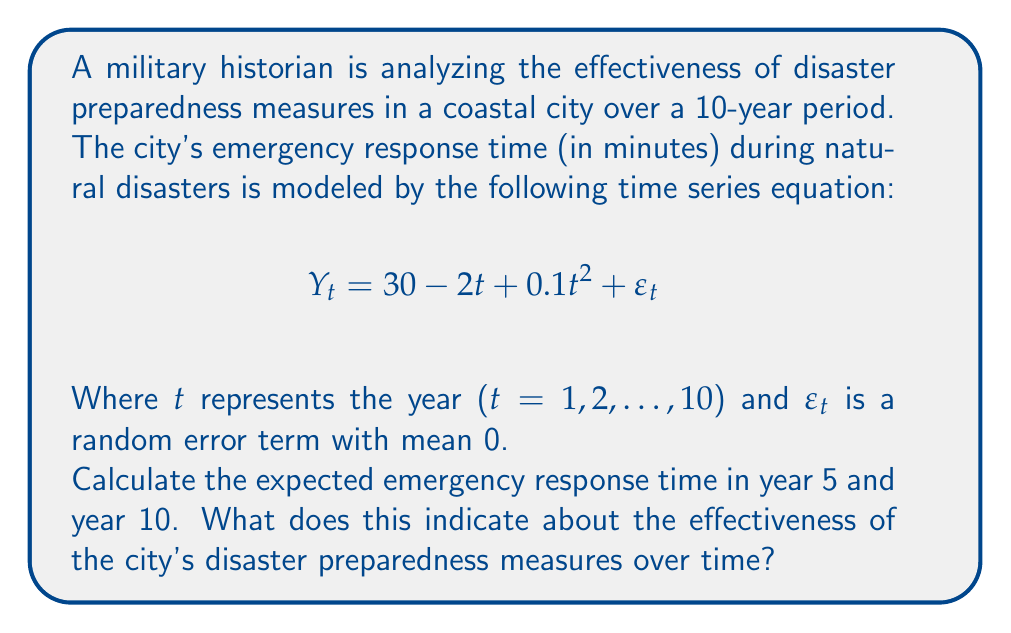Give your solution to this math problem. To solve this problem, we need to use the given time series equation and plug in the values for t (year) to calculate the expected emergency response times.

1. For year 5 (t = 5):
   $$Y_5 = 30 - 2(5) + 0.1(5^2) + \varepsilon_5$$
   $$Y_5 = 30 - 10 + 0.1(25) + \varepsilon_5$$
   $$Y_5 = 30 - 10 + 2.5 + \varepsilon_5$$
   $$Y_5 = 22.5 + \varepsilon_5$$

   Since $\varepsilon_t$ has a mean of 0, the expected value of $Y_5$ is 22.5 minutes.

2. For year 10 (t = 10):
   $$Y_{10} = 30 - 2(10) + 0.1(10^2) + \varepsilon_{10}$$
   $$Y_{10} = 30 - 20 + 0.1(100) + \varepsilon_{10}$$
   $$Y_{10} = 30 - 20 + 10 + \varepsilon_{10}$$
   $$Y_{10} = 20 + \varepsilon_{10}$$

   The expected value of $Y_{10}$ is 20 minutes.

Interpretation:
The expected emergency response time decreased from 22.5 minutes in year 5 to 20 minutes in year 10. This indicates an improvement in the city's disaster preparedness measures over time.

However, it's important to note that the time series equation includes a quadratic term ($0.1t^2$), which suggests that the rate of improvement is slowing down. In the long term, if this trend continues, the emergency response time might start to increase again.
Answer: Expected emergency response time in year 5: 22.5 minutes
Expected emergency response time in year 10: 20 minutes

This indicates an improvement in the city's disaster preparedness measures over time, but with a potentially diminishing rate of improvement due to the quadratic term in the model. 